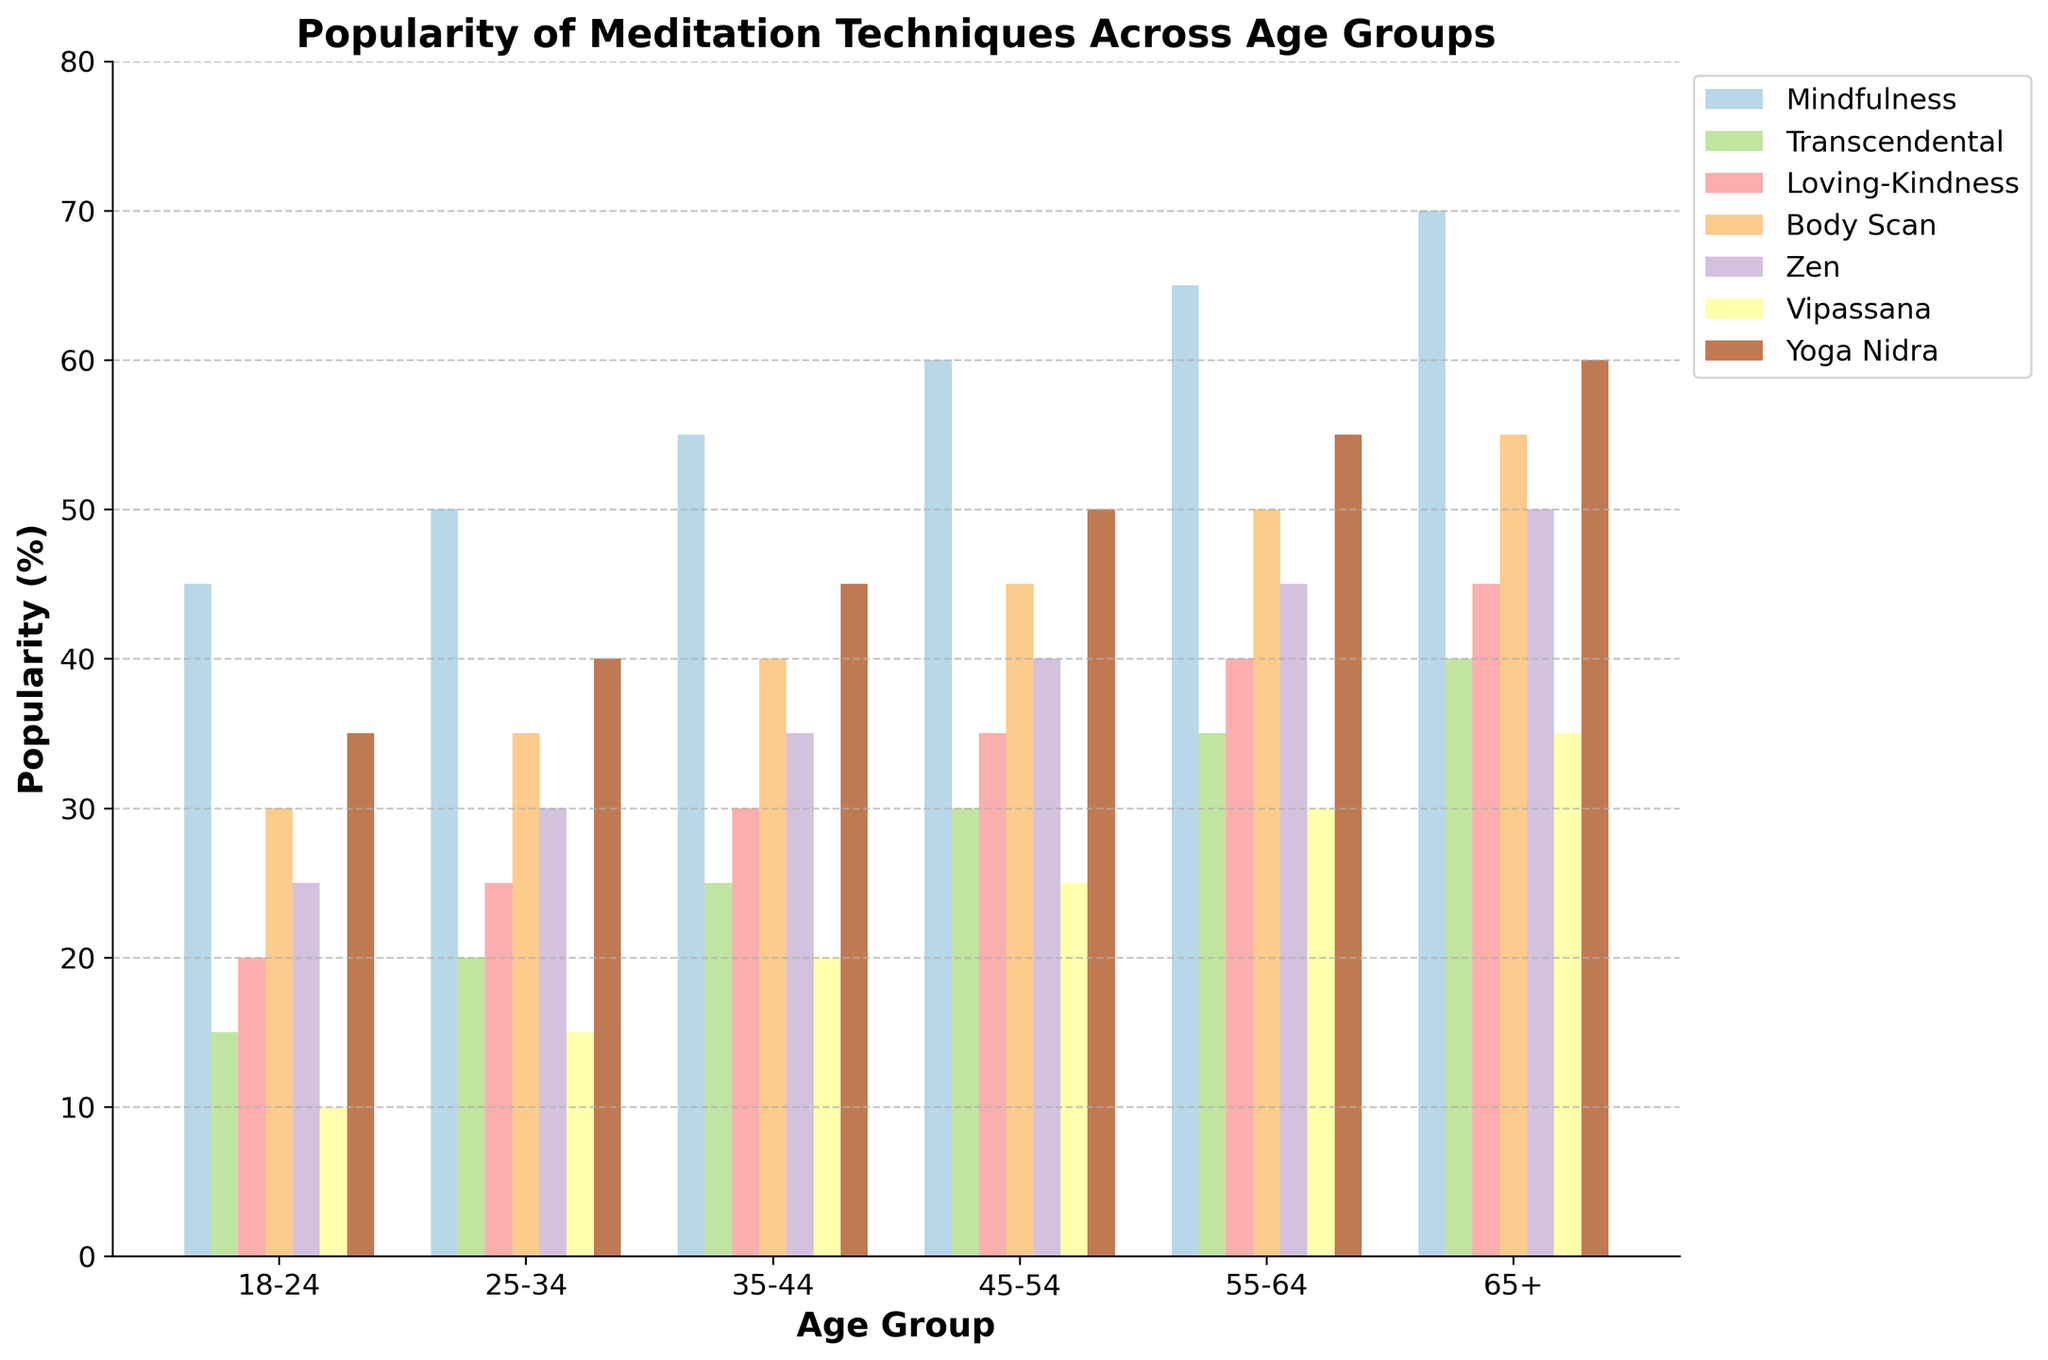Which age group has the highest popularity for Loving-Kindness meditation? To find the answer, look for the highest bar representing Loving-Kindness meditation across all age groups. The tallest bar for Loving-Kindness meditation is found in the 65+ age group.
Answer: 65+ Which meditation technique is most popular among the 25-34 age group? Check the heights of the bars within the 25-34 age group for all meditation techniques. The tallest bar represents Yoga Nidra.
Answer: Yoga Nidra How does the popularity of Zen meditation change with age? Observe the bars for Zen meditation across all age groups. The popularity increases progressively from 25 for 18-24 years to 50 for 65+ years.
Answer: It increases What is the sum of the popularity percentages for Mindfulness and Body Scan meditation techniques among the 45-54 age group? Find the percentages for Mindfulness (60) and Body Scan (45) in the 45-54 age group, then add them up: 60 + 45 = 105.
Answer: 105 Compare the popularity of Transcendental and Vipassana meditation for the age group 35-44. Which one is more popular? Find the heights of the bars for both techniques in the 35-44 age group. Transcendental has a value of 25, whereas Vipassana has a value of 20, making Transcendental more popular.
Answer: Transcendental Which meditation technique consistently increases in popularity across all age groups? Review each meditation technique across all age groups to identify which one shows a consistent increase in the height of its bars. Mindfulness meditation shows a consistent increase from 18-24 to 65+.
Answer: Mindfulness What is the average popularity of Yoga Nidra meditation across all age groups? Sum the percentages for Yoga Nidra across all age groups (35 + 40 + 45 + 50 + 55 + 60) and divide by the number of age groups (6): (35 + 40 + 45 + 50 + 55 + 60) / 6 = 47.5.
Answer: 47.5 Is the popularity of Body Scan meditation higher among 55-64 years compared to 25-34 years? Check the heights of the bars for Body Scan meditation in these two age groups. The 55-64 group has a value of 50, while the 25-34 group has a value of 35. Hence, it is higher for the 55-64 age group.
Answer: Yes 